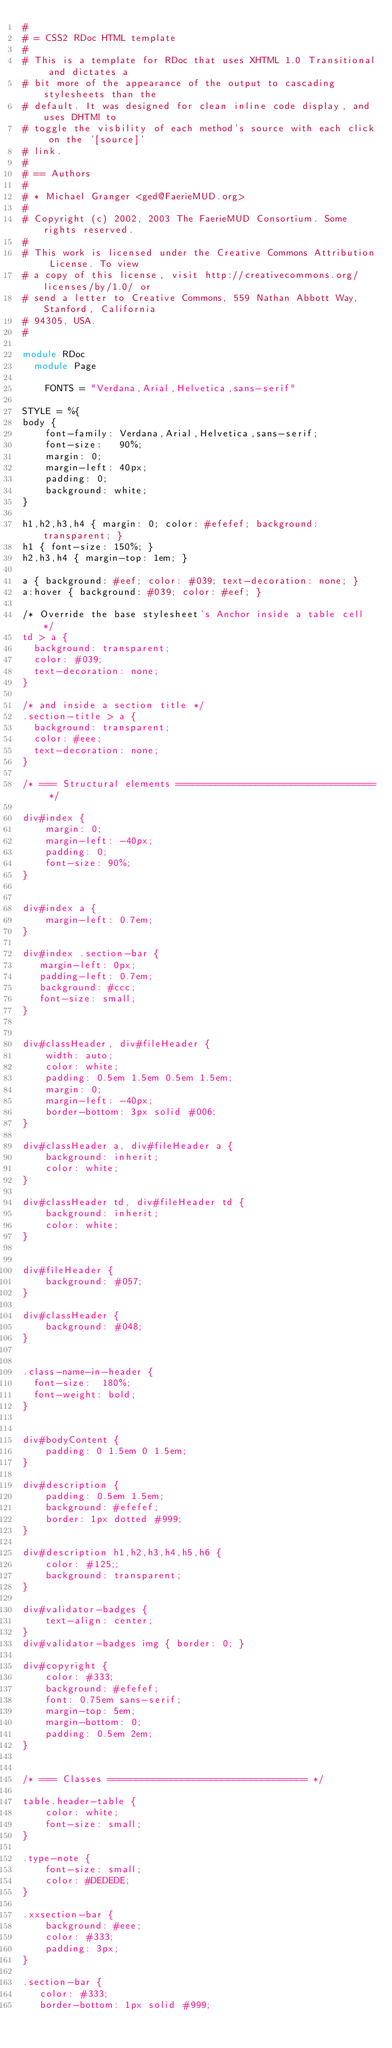Convert code to text. <code><loc_0><loc_0><loc_500><loc_500><_Ruby_>#
# = CSS2 RDoc HTML template
#
# This is a template for RDoc that uses XHTML 1.0 Transitional and dictates a
# bit more of the appearance of the output to cascading stylesheets than the
# default. It was designed for clean inline code display, and uses DHTMl to
# toggle the visbility of each method's source with each click on the '[source]'
# link.
#
# == Authors
#
# * Michael Granger <ged@FaerieMUD.org>
#
# Copyright (c) 2002, 2003 The FaerieMUD Consortium. Some rights reserved.
#
# This work is licensed under the Creative Commons Attribution License. To view
# a copy of this license, visit http://creativecommons.org/licenses/by/1.0/ or
# send a letter to Creative Commons, 559 Nathan Abbott Way, Stanford, California
# 94305, USA.
#

module RDoc
  module Page

    FONTS = "Verdana,Arial,Helvetica,sans-serif"

STYLE = %{
body {
    font-family: Verdana,Arial,Helvetica,sans-serif;
    font-size:   90%;
    margin: 0;
    margin-left: 40px;
    padding: 0;
    background: white;
}

h1,h2,h3,h4 { margin: 0; color: #efefef; background: transparent; }
h1 { font-size: 150%; }
h2,h3,h4 { margin-top: 1em; }

a { background: #eef; color: #039; text-decoration: none; }
a:hover { background: #039; color: #eef; }

/* Override the base stylesheet's Anchor inside a table cell */
td > a {
  background: transparent;
  color: #039;
  text-decoration: none;
}

/* and inside a section title */
.section-title > a {
  background: transparent;
  color: #eee;
  text-decoration: none;
}

/* === Structural elements =================================== */

div#index {
    margin: 0;
    margin-left: -40px;
    padding: 0;
    font-size: 90%;
}


div#index a {
    margin-left: 0.7em;
}

div#index .section-bar {
   margin-left: 0px;
   padding-left: 0.7em;
   background: #ccc;
   font-size: small;
}


div#classHeader, div#fileHeader {
    width: auto;
    color: white;
    padding: 0.5em 1.5em 0.5em 1.5em;
    margin: 0;
    margin-left: -40px;
    border-bottom: 3px solid #006;
}

div#classHeader a, div#fileHeader a {
    background: inherit;
    color: white;
}

div#classHeader td, div#fileHeader td {
    background: inherit;
    color: white;
}


div#fileHeader {
    background: #057;
}

div#classHeader {
    background: #048;
}


.class-name-in-header {
  font-size:  180%;
  font-weight: bold;
}


div#bodyContent {
    padding: 0 1.5em 0 1.5em;
}

div#description {
    padding: 0.5em 1.5em;
    background: #efefef;
    border: 1px dotted #999;
}

div#description h1,h2,h3,h4,h5,h6 {
    color: #125;;
    background: transparent;
}

div#validator-badges {
    text-align: center;
}
div#validator-badges img { border: 0; }

div#copyright {
    color: #333;
    background: #efefef;
    font: 0.75em sans-serif;
    margin-top: 5em;
    margin-bottom: 0;
    padding: 0.5em 2em;
}


/* === Classes =================================== */

table.header-table {
    color: white;
    font-size: small;
}

.type-note {
    font-size: small;
    color: #DEDEDE;
}

.xxsection-bar {
    background: #eee;
    color: #333;
    padding: 3px;
}

.section-bar {
   color: #333;
   border-bottom: 1px solid #999;</code> 